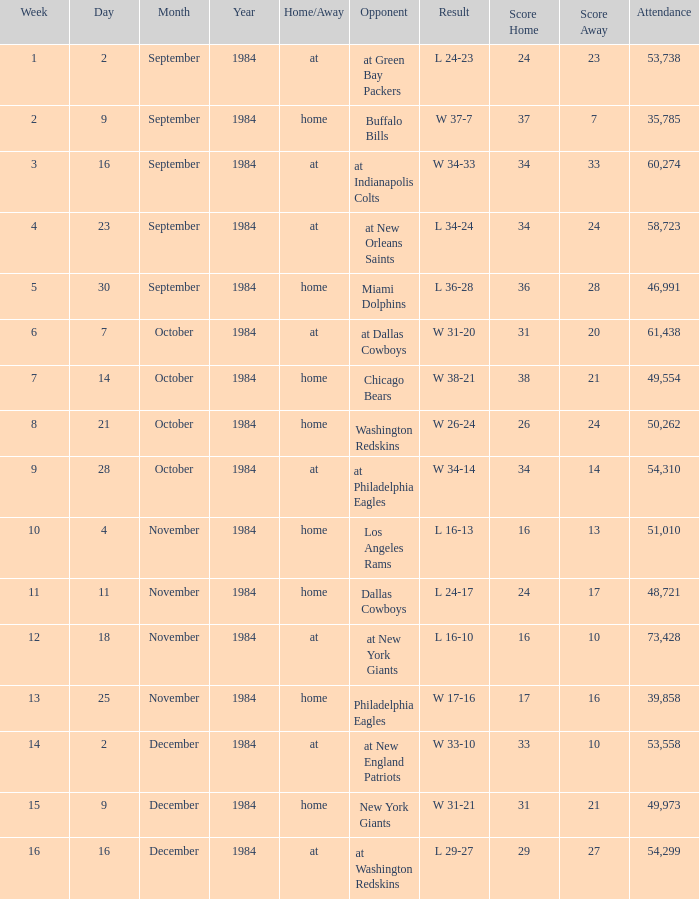What was the result in a week lower than 10 with an opponent of Chicago Bears? W 38-21. 